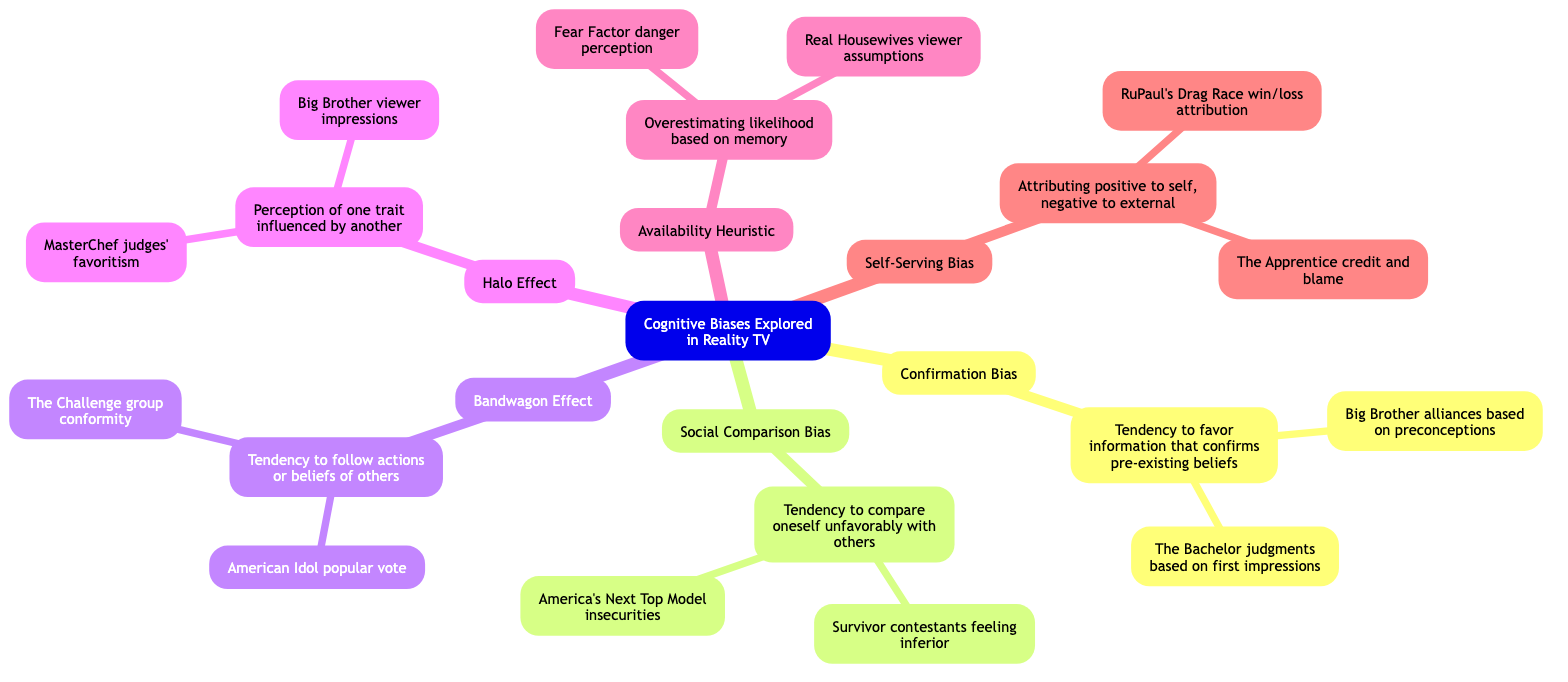What is the core topic of the mind map? The core topic is presented at the very center of the diagram, which summarizes the overall focus of the mind map.
Answer: Cognitive Biases Explored in Reality TV How many cognitive biases are explored in the mind map? By counting the subtopics listed underneath the core topic, we find there are six distinct cognitive biases presented.
Answer: 6 What is the definition of Confirmation Bias? The definition can be found directly under its subtopic, indicating the meaning of the bias as shown in the diagram.
Answer: Tendency to favor information that confirms pre-existing beliefs Provide one example of Social Comparison Bias from reality TV. There are several examples under the Social Comparison Bias subtopic; selecting one provides a direct instance related to the bias.
Answer: Contestants on "Survivor" feeling inferior to stronger players What connects the Bandwagon Effect to its definition in the mind map? The relationship is shown through a structured connection from the subtopic to its definition, illustrating how the bias is described.
Answer: Tendency to follow the actions or beliefs of others Which reality TV show illustrates the Halo Effect through judges' favoritism? The diagram explicitly states the particular show under the Halo Effect subtopic that details this example of bias.
Answer: MasterChef How does the Availability Heuristic relate to viewer assumptions on "Real Housewives"? This requires reasoning through the nodes to connect the definition of the Availability Heuristic with the specific example listed in the diagram.
Answer: Viewers assuming frequent arguments on "Real Housewives" reflect reality rather than production choices What type of bias involves attributing positive outcomes to oneself? The naming of the bias is outlined in the subtopic, from which its essence can be directly identified.
Answer: Self-Serving Bias Which cognitive bias would likely make viewers follow popular contestants on "American Idol"? By analyzing the description of the Bandwagon Effect, it is clear which bias encourages this behavior among viewers.
Answer: Bandwagon Effect 